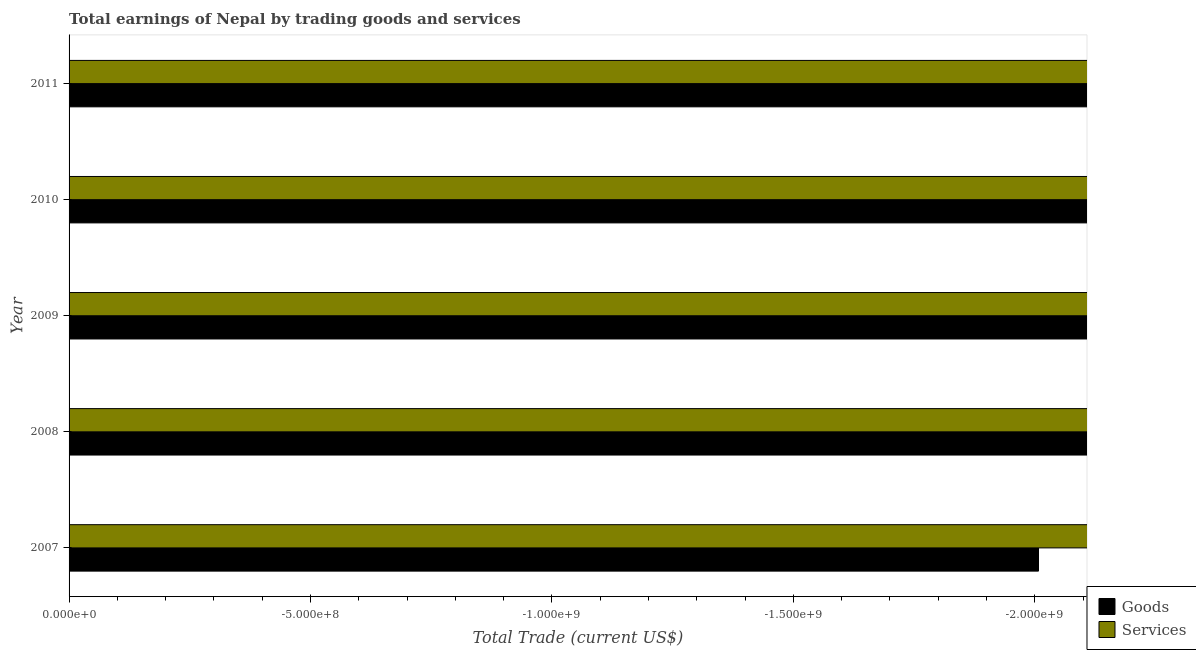How many different coloured bars are there?
Offer a very short reply. 0. Are the number of bars per tick equal to the number of legend labels?
Offer a very short reply. No. What is the label of the 2nd group of bars from the top?
Ensure brevity in your answer.  2010. What is the difference between the amount earned by trading goods in 2009 and the amount earned by trading services in 2007?
Offer a very short reply. 0. What is the average amount earned by trading services per year?
Your answer should be compact. 0. How many bars are there?
Keep it short and to the point. 0. Are all the bars in the graph horizontal?
Offer a terse response. Yes. What is the difference between two consecutive major ticks on the X-axis?
Offer a very short reply. 5.00e+08. Does the graph contain grids?
Provide a succinct answer. No. Where does the legend appear in the graph?
Provide a short and direct response. Bottom right. What is the title of the graph?
Your answer should be compact. Total earnings of Nepal by trading goods and services. Does "Services" appear as one of the legend labels in the graph?
Provide a succinct answer. Yes. What is the label or title of the X-axis?
Your response must be concise. Total Trade (current US$). What is the label or title of the Y-axis?
Your answer should be compact. Year. What is the Total Trade (current US$) of Goods in 2007?
Your response must be concise. 0. What is the Total Trade (current US$) of Services in 2007?
Your answer should be very brief. 0. What is the Total Trade (current US$) of Services in 2008?
Your answer should be compact. 0. What is the Total Trade (current US$) in Services in 2009?
Offer a terse response. 0. What is the Total Trade (current US$) of Goods in 2010?
Provide a short and direct response. 0. What is the Total Trade (current US$) in Services in 2011?
Make the answer very short. 0. 